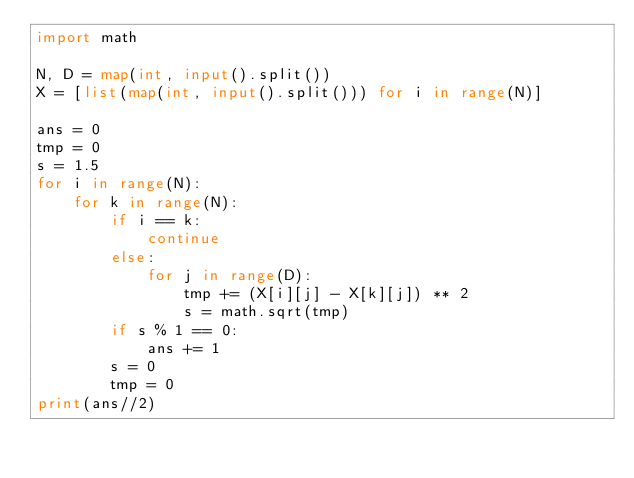<code> <loc_0><loc_0><loc_500><loc_500><_Python_>import math

N, D = map(int, input().split())
X = [list(map(int, input().split())) for i in range(N)]

ans = 0
tmp = 0
s = 1.5
for i in range(N):
    for k in range(N):
        if i == k:
            continue
        else:
            for j in range(D):
                tmp += (X[i][j] - X[k][j]) ** 2
                s = math.sqrt(tmp)
        if s % 1 == 0:
            ans += 1
        s = 0
        tmp = 0
print(ans//2)
</code> 